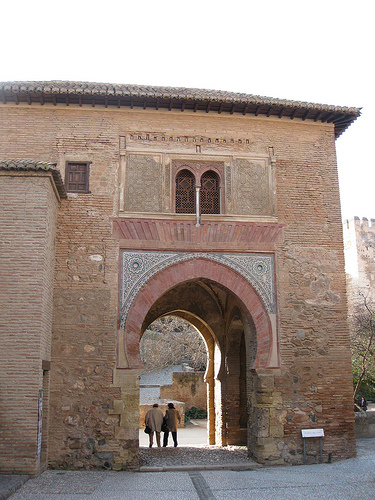<image>
Is the window behind the person? No. The window is not behind the person. From this viewpoint, the window appears to be positioned elsewhere in the scene. 